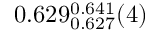<formula> <loc_0><loc_0><loc_500><loc_500>0 . 6 2 9 _ { 0 . 6 2 7 } ^ { 0 . 6 4 1 } ( 4 )</formula> 